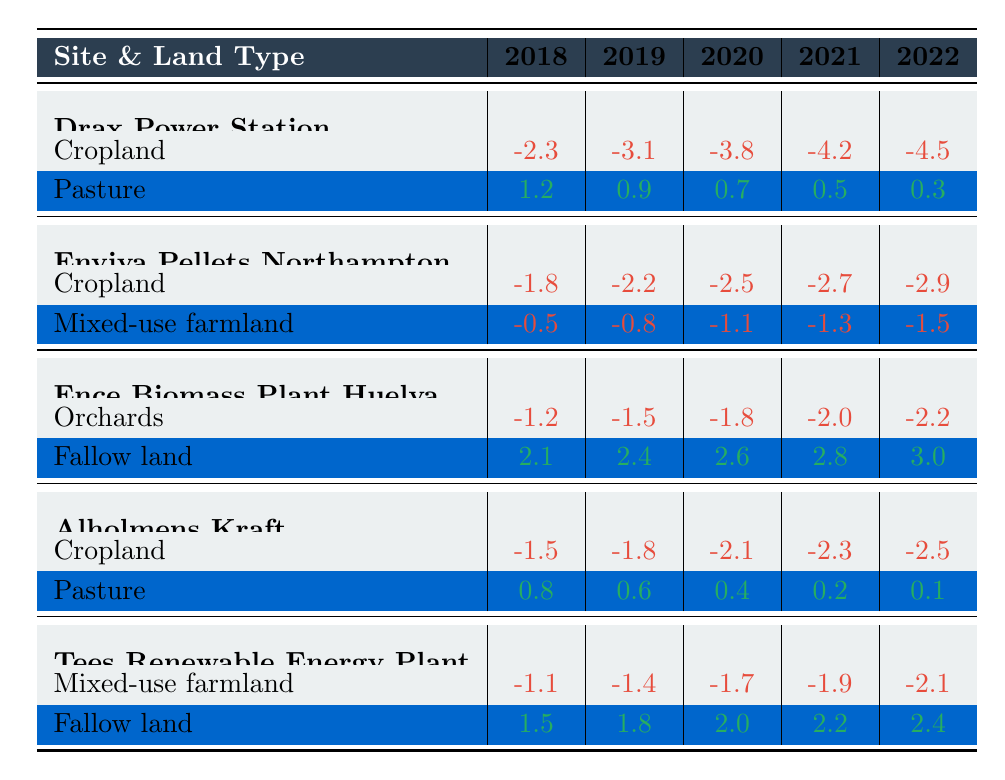What is the value for cropland around Drax Power Station in 2022? The table shows that the cropland value for Drax Power Station in 2022 is -4.5.
Answer: -4.5 What was the trend in pasture values at Drax Power Station from 2018 to 2022? Reviewing the pasture values: 1.2, 0.9, 0.7, 0.5, and 0.3, we see a decreasing trend over the years.
Answer: Decreasing trend Which site had the least negative impact on mixed-use farmland in 2020? In 2020, Tees Renewable Energy Plant had a mixed-use farmland value of -1.7, which is less negative compared to Enviva Pellets Northampton's -1.1.
Answer: Tees Renewable Energy Plant What is the average reduction in the cropland value for Enviva Pellets Northampton over the years 2018 to 2022? Adding the cropland values: -1.8, -2.2, -2.5, -2.7, -2.9 results in -12.1, then divide by 5 gives an average of -2.42.
Answer: -2.42 Did the fallow land values increase at Ence Biomass Plant Huelva from 2018 to 2022? The fallow land values are 2.1, 2.4, 2.6, 2.8, and 3.0, showing a clear increase over these years.
Answer: Yes Which renewable energy site experienced the largest increase in fallow land value from 2018 to 2022? For Tees Renewable Energy Plant, fallow land values changed from 1.5 in 2018 to 2.4 in 2022, giving an increase of 0.9. This is greater than that of Ence Biomass Plant Huelva, which increased by 0.9 as well, but is lesser compared to Drax.
Answer: Tees Renewable Energy Plant Calculate the total negative impact on cropland in 2021 across all sites. The cropland values in 2021 are -4.2 (Drax) + -2.7 (Enviva) + -2.3 (Alholmens) + -1.9 (Tees). Adding these gives -11.1.
Answer: -11.1 Which site showed the most significant positive change in agricultural land use from 2018 to 2022? Ence Biomass Plant Huelva demonstrated the most significant positive change with fallow land values rising from 2.1 to 3.0, a total increase of 0.9.
Answer: Ence Biomass Plant Huelva How much did pasture values decrease at Alholmens Kraft from 2018 to 2022? The pasture values decreased from 0.8 in 2018 to 0.1 in 2022. This is a decrease of 0.7.
Answer: 0.7 Was there any year when the pasture values exceeded 1.0 for Drax Power Station? Yes, in 2018 the pasture value was 1.2, which exceeds 1.0.
Answer: Yes 